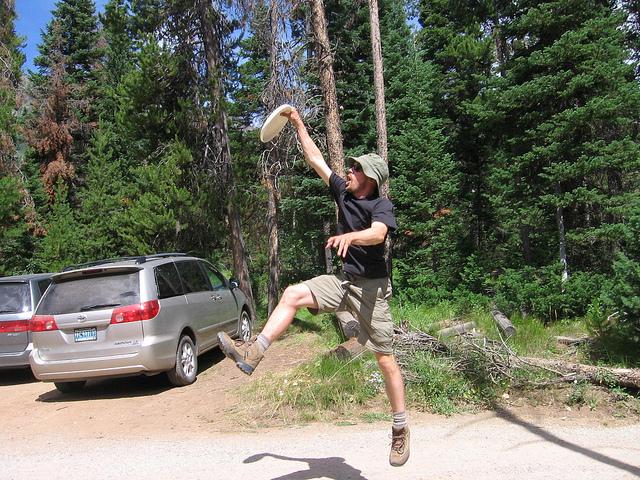What is the man doing in air in the picture?
Answer briefly. Catching frisbee. How many people can be seen?
Short answer required. 1. Is the man in motion?
Quick response, please. Yes. Was that a great catch?
Be succinct. Yes. 